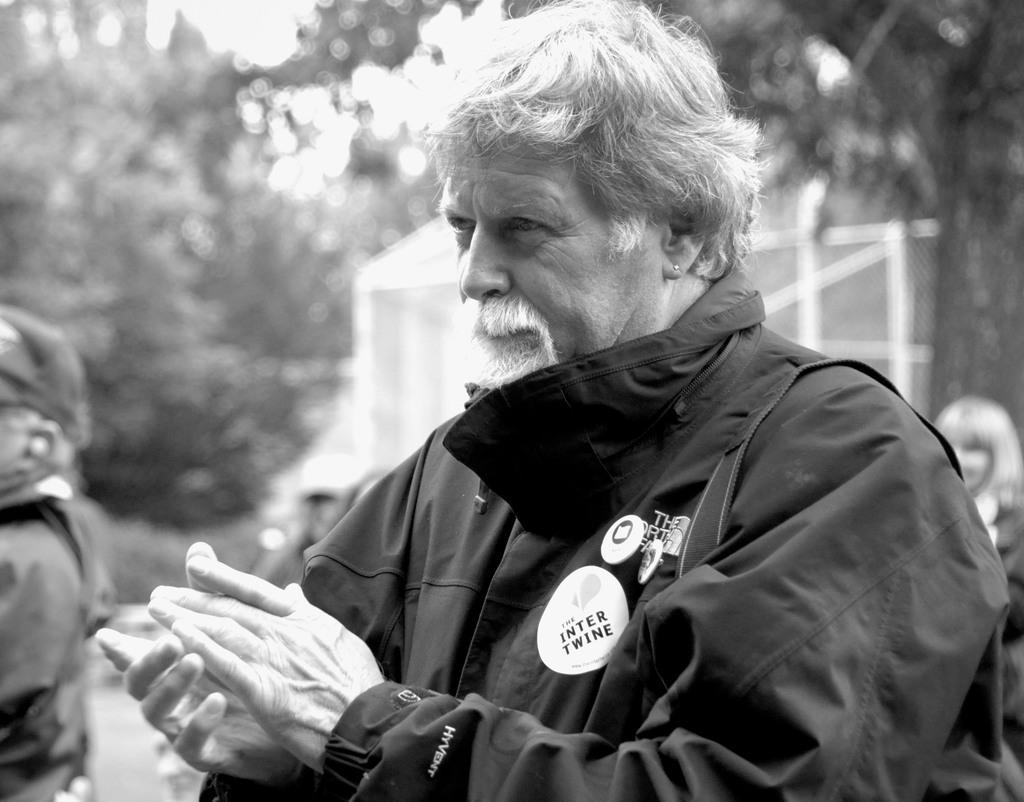Could you give a brief overview of what you see in this image? In this picture we see an old man looking at someone and clapping. 